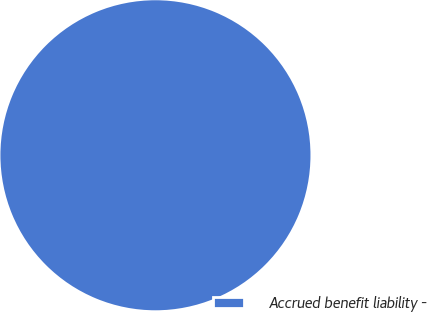Convert chart. <chart><loc_0><loc_0><loc_500><loc_500><pie_chart><fcel>Accrued benefit liability -<nl><fcel>100.0%<nl></chart> 